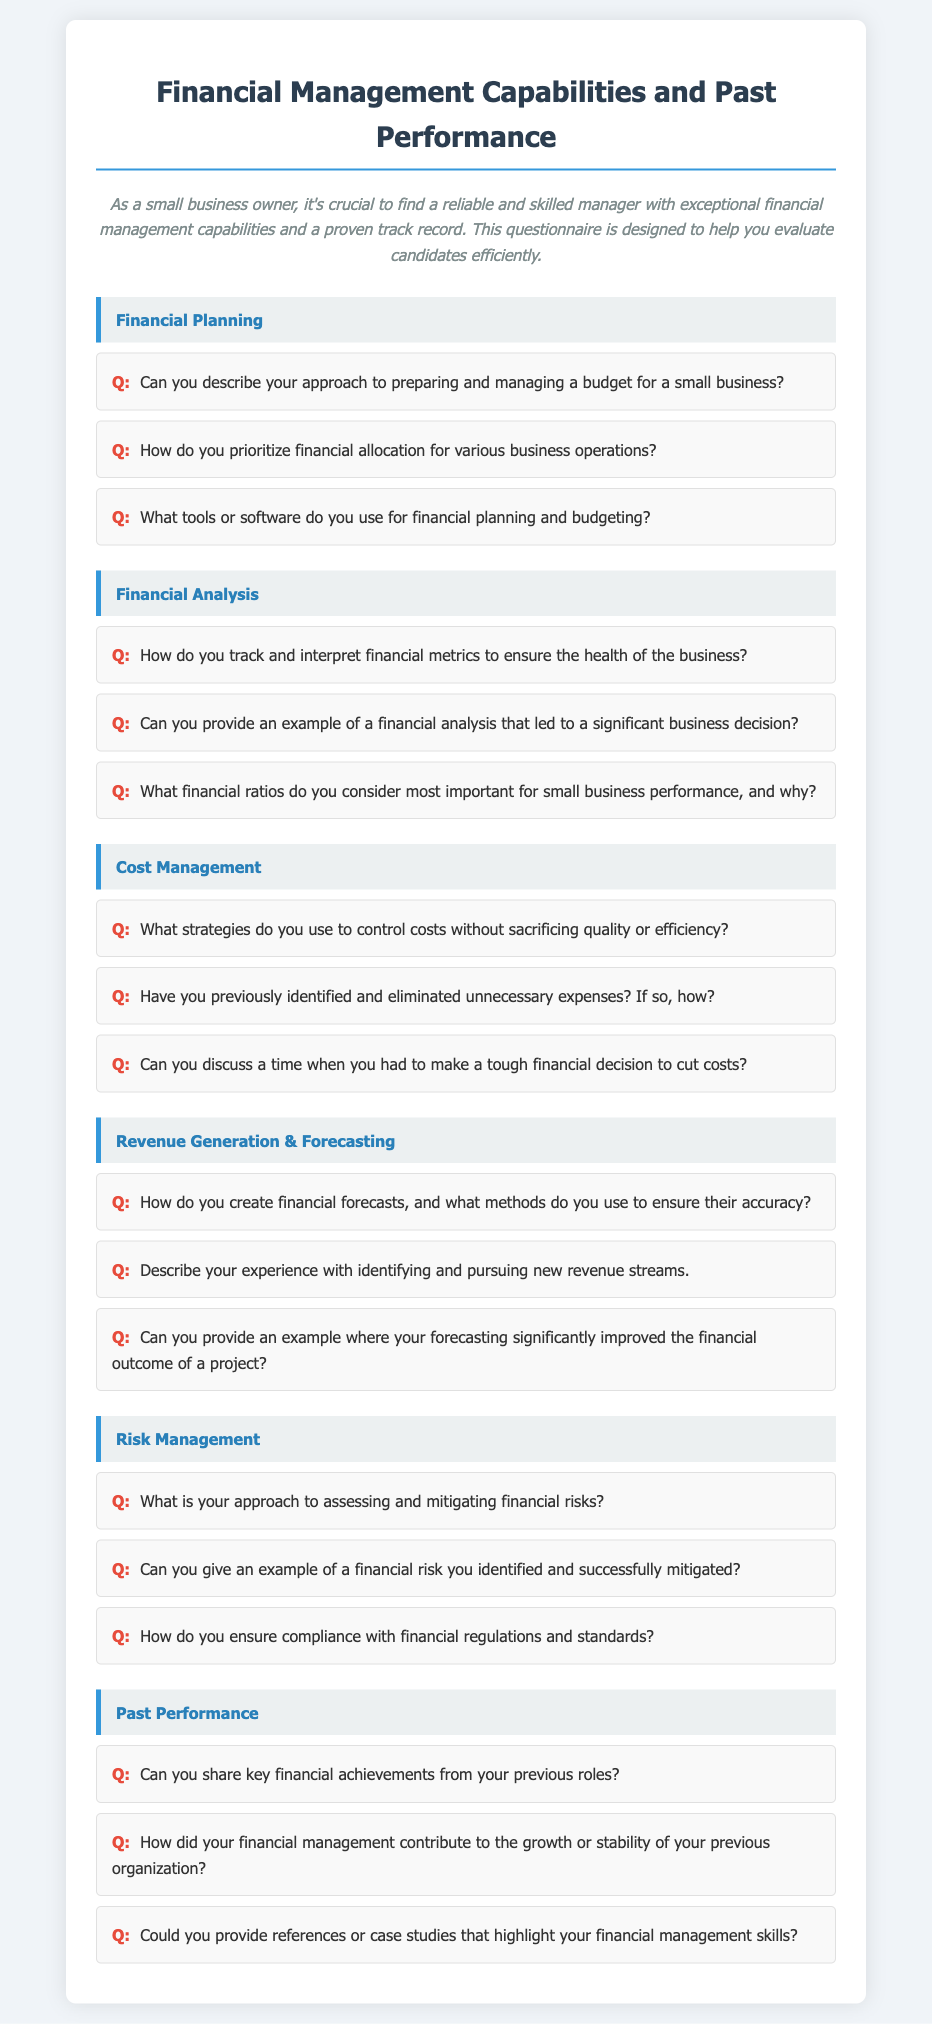What is the title of the document? The title is presented prominently at the top of the rendered document, which helps identify the purpose of the questionnaire.
Answer: Financial Management Capabilities and Past Performance Questionnaire How many categories are listed in the questionnaire? The categories are clearly divided sections within the questionnaire, making it easy to count them.
Answer: Six What is the first question in the Financial Planning category? The first question is located directly under the Financial Planning section header, indicating the starting point of inquiries about financial planning.
Answer: Can you describe your approach to preparing and managing a budget for a small business? What color is used for the category background? The background color for each category is specified to enhance visual separation of the topics.
Answer: Light gray What is the main purpose of the questionnaire? The purpose is summarized in the introductory paragraph, providing context for the candidates being evaluated.
Answer: Evaluate candidates efficiently How does the questionnaire present the questions? The style of presenting questions is important for clarity and engagement, which is a pattern seen throughout the document.
Answer: As short-answer questions What is the last question in the Past Performance category? The last question in a category gives insight into the depth of evaluation for past achievements and management skills.
Answer: Could you provide references or case studies that highlight your financial management skills? 